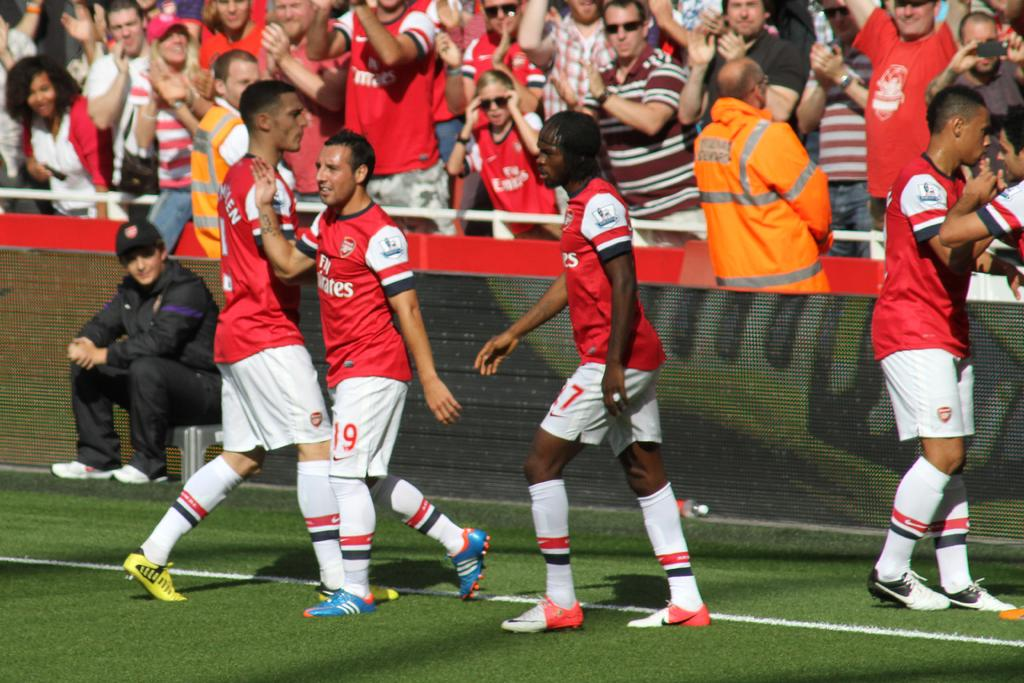<image>
Summarize the visual content of the image. some soccer players with one that has the number 19 on 